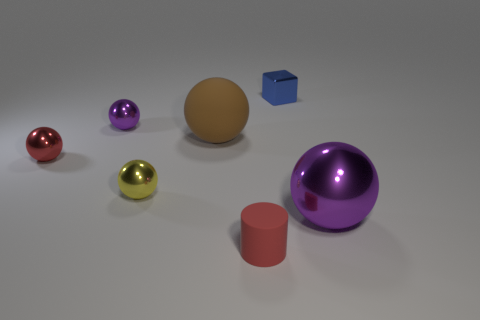Are there an equal number of large brown balls in front of the big purple metallic sphere and big things left of the blue metallic block?
Offer a terse response. No. There is a large brown rubber ball; are there any objects to the right of it?
Give a very brief answer. Yes. The sphere that is to the right of the large brown rubber ball is what color?
Offer a terse response. Purple. The small thing right of the red thing in front of the yellow metal sphere is made of what material?
Offer a terse response. Metal. Is the number of small shiny things that are in front of the large rubber sphere less than the number of balls behind the small yellow object?
Ensure brevity in your answer.  Yes. What number of purple things are cylinders or big cubes?
Your answer should be very brief. 0. Are there an equal number of things that are behind the tiny block and small green metal balls?
Your answer should be very brief. Yes. What number of objects are either cylinders or things that are to the left of the large purple metallic ball?
Your answer should be very brief. 6. Is there another small red sphere that has the same material as the red sphere?
Keep it short and to the point. No. There is another big thing that is the same shape as the brown object; what color is it?
Offer a very short reply. Purple. 